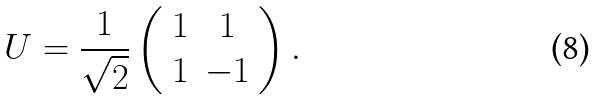Convert formula to latex. <formula><loc_0><loc_0><loc_500><loc_500>U = \frac { 1 } { \sqrt { 2 } } \left ( \begin{array} { c c } 1 & 1 \\ 1 & - 1 \end{array} \right ) .</formula> 